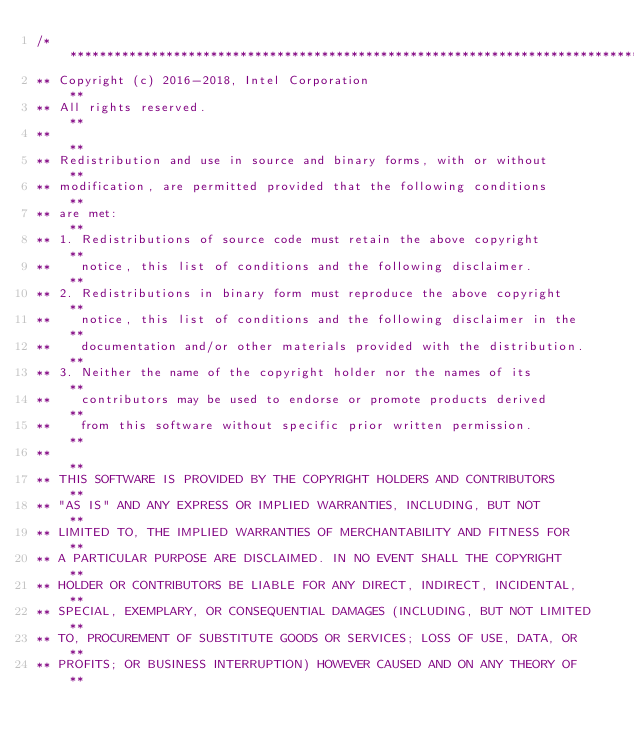Convert code to text. <code><loc_0><loc_0><loc_500><loc_500><_C_>/******************************************************************************
** Copyright (c) 2016-2018, Intel Corporation                                **
** All rights reserved.                                                      **
**                                                                           **
** Redistribution and use in source and binary forms, with or without        **
** modification, are permitted provided that the following conditions        **
** are met:                                                                  **
** 1. Redistributions of source code must retain the above copyright         **
**    notice, this list of conditions and the following disclaimer.          **
** 2. Redistributions in binary form must reproduce the above copyright      **
**    notice, this list of conditions and the following disclaimer in the    **
**    documentation and/or other materials provided with the distribution.   **
** 3. Neither the name of the copyright holder nor the names of its          **
**    contributors may be used to endorse or promote products derived        **
**    from this software without specific prior written permission.          **
**                                                                           **
** THIS SOFTWARE IS PROVIDED BY THE COPYRIGHT HOLDERS AND CONTRIBUTORS       **
** "AS IS" AND ANY EXPRESS OR IMPLIED WARRANTIES, INCLUDING, BUT NOT         **
** LIMITED TO, THE IMPLIED WARRANTIES OF MERCHANTABILITY AND FITNESS FOR     **
** A PARTICULAR PURPOSE ARE DISCLAIMED. IN NO EVENT SHALL THE COPYRIGHT      **
** HOLDER OR CONTRIBUTORS BE LIABLE FOR ANY DIRECT, INDIRECT, INCIDENTAL,    **
** SPECIAL, EXEMPLARY, OR CONSEQUENTIAL DAMAGES (INCLUDING, BUT NOT LIMITED  **
** TO, PROCUREMENT OF SUBSTITUTE GOODS OR SERVICES; LOSS OF USE, DATA, OR    **
** PROFITS; OR BUSINESS INTERRUPTION) HOWEVER CAUSED AND ON ANY THEORY OF    **</code> 